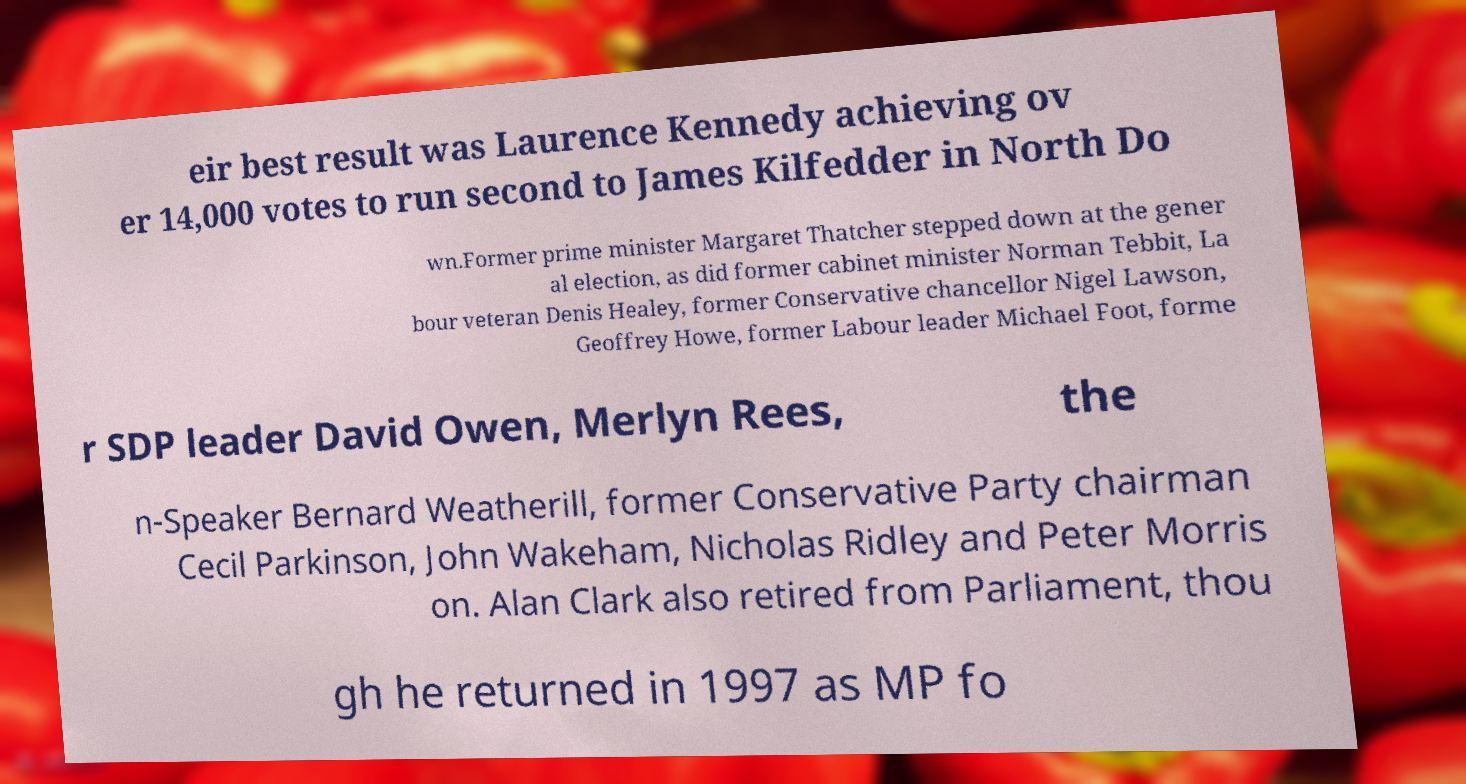Can you read and provide the text displayed in the image?This photo seems to have some interesting text. Can you extract and type it out for me? eir best result was Laurence Kennedy achieving ov er 14,000 votes to run second to James Kilfedder in North Do wn.Former prime minister Margaret Thatcher stepped down at the gener al election, as did former cabinet minister Norman Tebbit, La bour veteran Denis Healey, former Conservative chancellor Nigel Lawson, Geoffrey Howe, former Labour leader Michael Foot, forme r SDP leader David Owen, Merlyn Rees, the n-Speaker Bernard Weatherill, former Conservative Party chairman Cecil Parkinson, John Wakeham, Nicholas Ridley and Peter Morris on. Alan Clark also retired from Parliament, thou gh he returned in 1997 as MP fo 